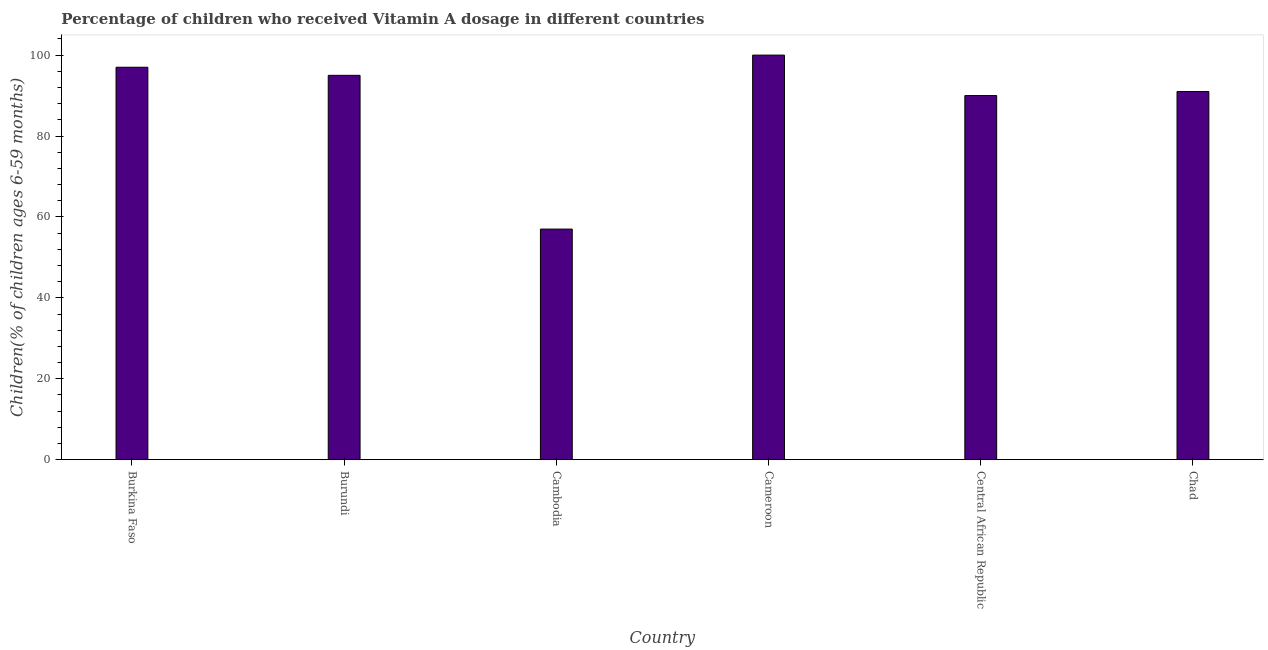What is the title of the graph?
Give a very brief answer. Percentage of children who received Vitamin A dosage in different countries. What is the label or title of the X-axis?
Your response must be concise. Country. What is the label or title of the Y-axis?
Your answer should be compact. Children(% of children ages 6-59 months). Across all countries, what is the minimum vitamin a supplementation coverage rate?
Make the answer very short. 57. In which country was the vitamin a supplementation coverage rate maximum?
Offer a very short reply. Cameroon. In which country was the vitamin a supplementation coverage rate minimum?
Offer a very short reply. Cambodia. What is the sum of the vitamin a supplementation coverage rate?
Make the answer very short. 530. What is the average vitamin a supplementation coverage rate per country?
Your answer should be compact. 88.33. What is the median vitamin a supplementation coverage rate?
Provide a short and direct response. 93. What is the ratio of the vitamin a supplementation coverage rate in Burkina Faso to that in Cambodia?
Your response must be concise. 1.7. Is the vitamin a supplementation coverage rate in Burundi less than that in Cameroon?
Provide a succinct answer. Yes. What is the difference between the highest and the second highest vitamin a supplementation coverage rate?
Your answer should be very brief. 3. What is the difference between the highest and the lowest vitamin a supplementation coverage rate?
Your response must be concise. 43. In how many countries, is the vitamin a supplementation coverage rate greater than the average vitamin a supplementation coverage rate taken over all countries?
Offer a very short reply. 5. What is the difference between two consecutive major ticks on the Y-axis?
Your response must be concise. 20. What is the Children(% of children ages 6-59 months) of Burkina Faso?
Give a very brief answer. 97. What is the Children(% of children ages 6-59 months) in Cameroon?
Ensure brevity in your answer.  100. What is the Children(% of children ages 6-59 months) in Chad?
Ensure brevity in your answer.  91. What is the difference between the Children(% of children ages 6-59 months) in Burkina Faso and Cambodia?
Offer a very short reply. 40. What is the difference between the Children(% of children ages 6-59 months) in Burkina Faso and Chad?
Your response must be concise. 6. What is the difference between the Children(% of children ages 6-59 months) in Cambodia and Cameroon?
Provide a short and direct response. -43. What is the difference between the Children(% of children ages 6-59 months) in Cambodia and Central African Republic?
Provide a short and direct response. -33. What is the difference between the Children(% of children ages 6-59 months) in Cambodia and Chad?
Your answer should be compact. -34. What is the difference between the Children(% of children ages 6-59 months) in Cameroon and Central African Republic?
Make the answer very short. 10. What is the ratio of the Children(% of children ages 6-59 months) in Burkina Faso to that in Burundi?
Your answer should be very brief. 1.02. What is the ratio of the Children(% of children ages 6-59 months) in Burkina Faso to that in Cambodia?
Ensure brevity in your answer.  1.7. What is the ratio of the Children(% of children ages 6-59 months) in Burkina Faso to that in Cameroon?
Ensure brevity in your answer.  0.97. What is the ratio of the Children(% of children ages 6-59 months) in Burkina Faso to that in Central African Republic?
Give a very brief answer. 1.08. What is the ratio of the Children(% of children ages 6-59 months) in Burkina Faso to that in Chad?
Make the answer very short. 1.07. What is the ratio of the Children(% of children ages 6-59 months) in Burundi to that in Cambodia?
Provide a succinct answer. 1.67. What is the ratio of the Children(% of children ages 6-59 months) in Burundi to that in Central African Republic?
Offer a terse response. 1.06. What is the ratio of the Children(% of children ages 6-59 months) in Burundi to that in Chad?
Provide a succinct answer. 1.04. What is the ratio of the Children(% of children ages 6-59 months) in Cambodia to that in Cameroon?
Your answer should be very brief. 0.57. What is the ratio of the Children(% of children ages 6-59 months) in Cambodia to that in Central African Republic?
Offer a terse response. 0.63. What is the ratio of the Children(% of children ages 6-59 months) in Cambodia to that in Chad?
Provide a short and direct response. 0.63. What is the ratio of the Children(% of children ages 6-59 months) in Cameroon to that in Central African Republic?
Provide a succinct answer. 1.11. What is the ratio of the Children(% of children ages 6-59 months) in Cameroon to that in Chad?
Keep it short and to the point. 1.1. 